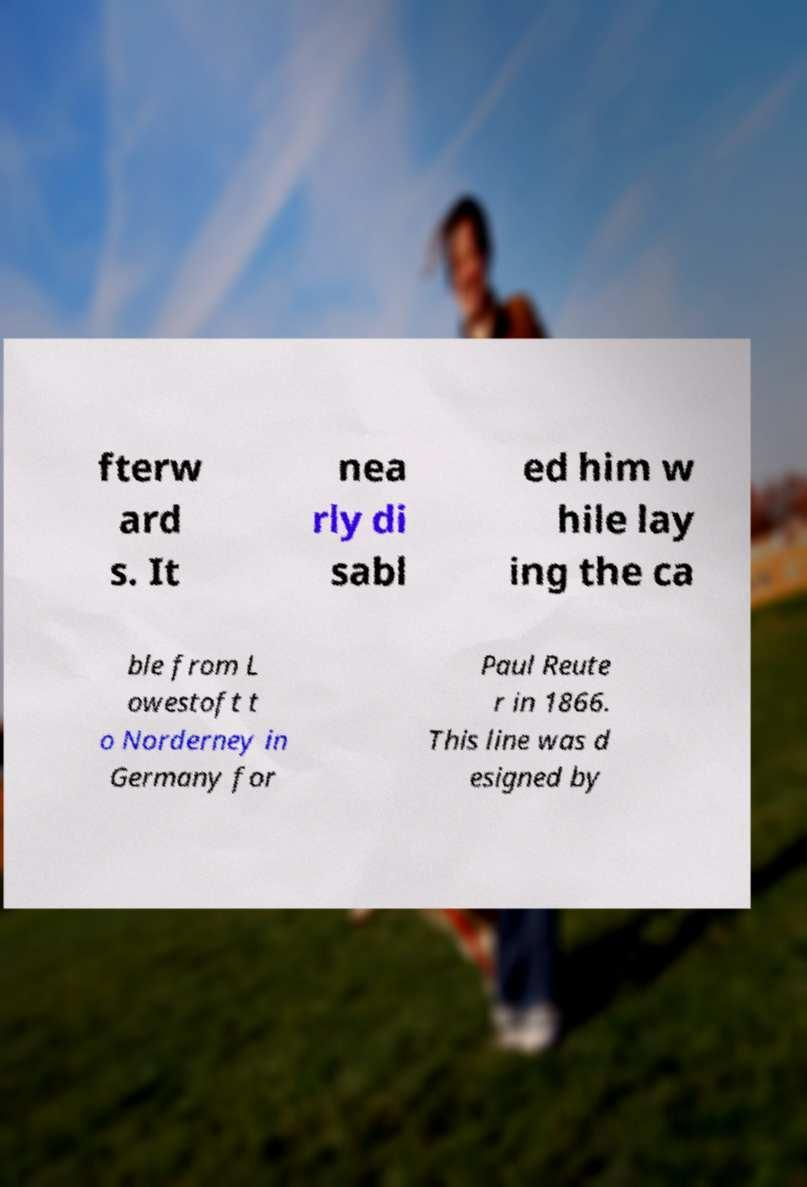I need the written content from this picture converted into text. Can you do that? fterw ard s. It nea rly di sabl ed him w hile lay ing the ca ble from L owestoft t o Norderney in Germany for Paul Reute r in 1866. This line was d esigned by 